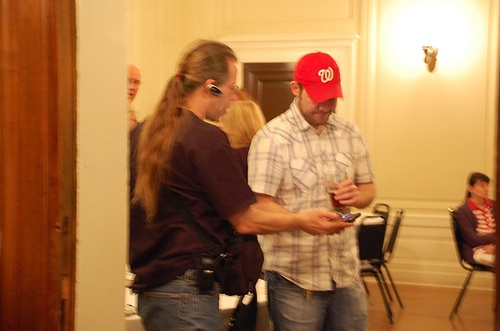Describe the objects in this image and their specific colors. I can see people in maroon, black, and brown tones, people in maroon, tan, and gray tones, handbag in maroon, black, and gray tones, people in maroon, black, brown, and tan tones, and people in maroon, red, and orange tones in this image. 